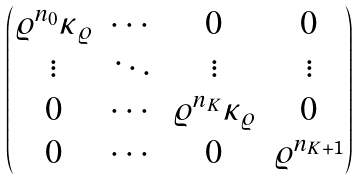<formula> <loc_0><loc_0><loc_500><loc_500>\begin{pmatrix} \varrho ^ { n _ { 0 } } \kappa _ { \varrho } & \cdots & 0 & 0 \\ \vdots & \ddots & \vdots & \vdots \\ 0 & \cdots & \varrho ^ { n _ { K } } \kappa _ { \varrho } & 0 \\ 0 & \cdots & 0 & \varrho ^ { n _ { K + 1 } } \end{pmatrix}</formula> 